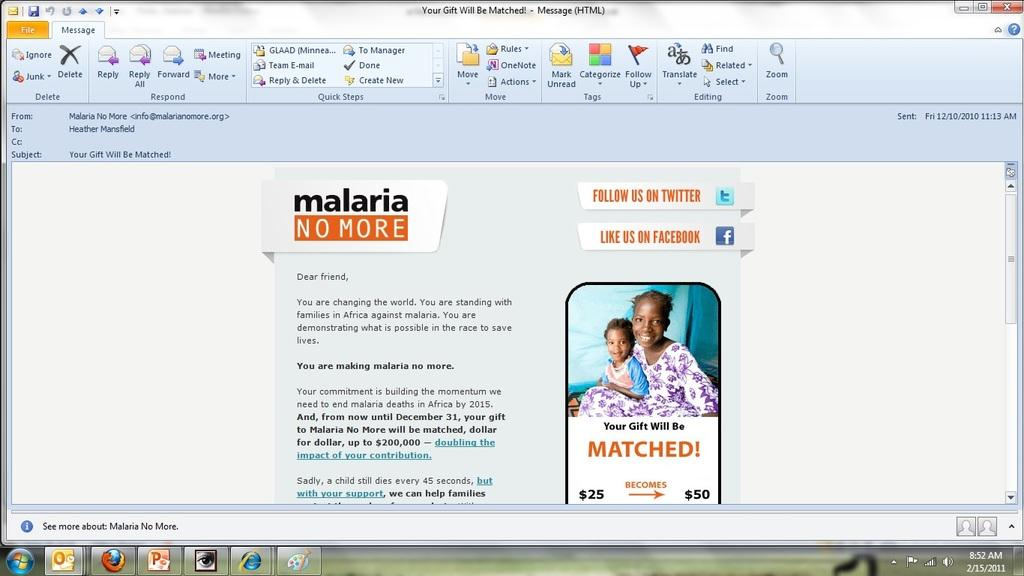<image>
Write a terse but informative summary of the picture. a screenshot of a website giving information for malaria prevention. 